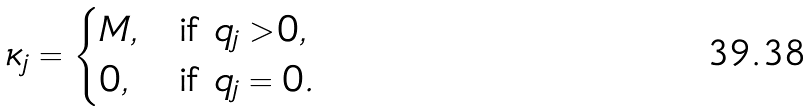Convert formula to latex. <formula><loc_0><loc_0><loc_500><loc_500>\kappa _ { j } = \begin{cases} M , & \text {if } q _ { j } > 0 , \\ 0 , & \text {if } q _ { j } = 0 . \end{cases}</formula> 